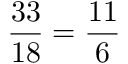Convert formula to latex. <formula><loc_0><loc_0><loc_500><loc_500>{ \frac { 3 3 } { 1 8 } } = { \frac { 1 1 } { 6 } }</formula> 